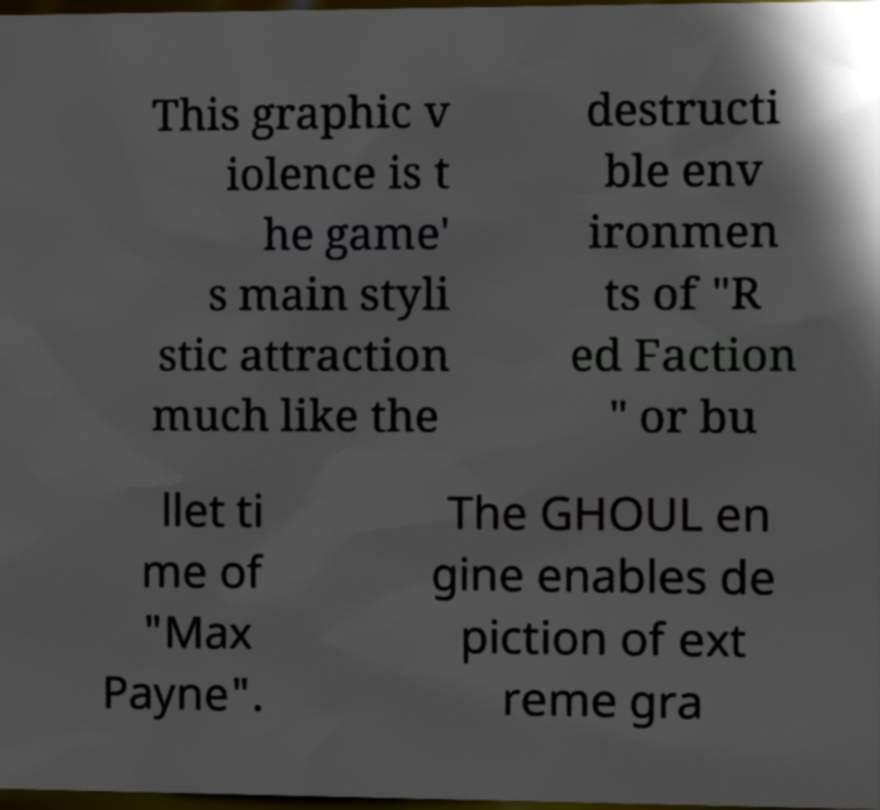Can you read and provide the text displayed in the image?This photo seems to have some interesting text. Can you extract and type it out for me? This graphic v iolence is t he game' s main styli stic attraction much like the destructi ble env ironmen ts of "R ed Faction " or bu llet ti me of "Max Payne". The GHOUL en gine enables de piction of ext reme gra 